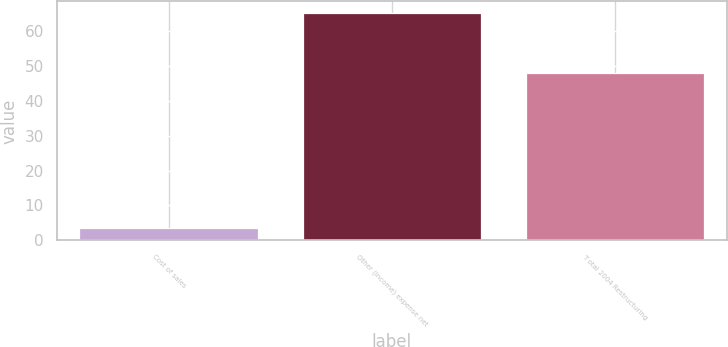Convert chart to OTSL. <chart><loc_0><loc_0><loc_500><loc_500><bar_chart><fcel>Cost of sales<fcel>Other (income) expense net<fcel>T otal 2004 Restructuring<nl><fcel>3.4<fcel>65.3<fcel>48<nl></chart> 